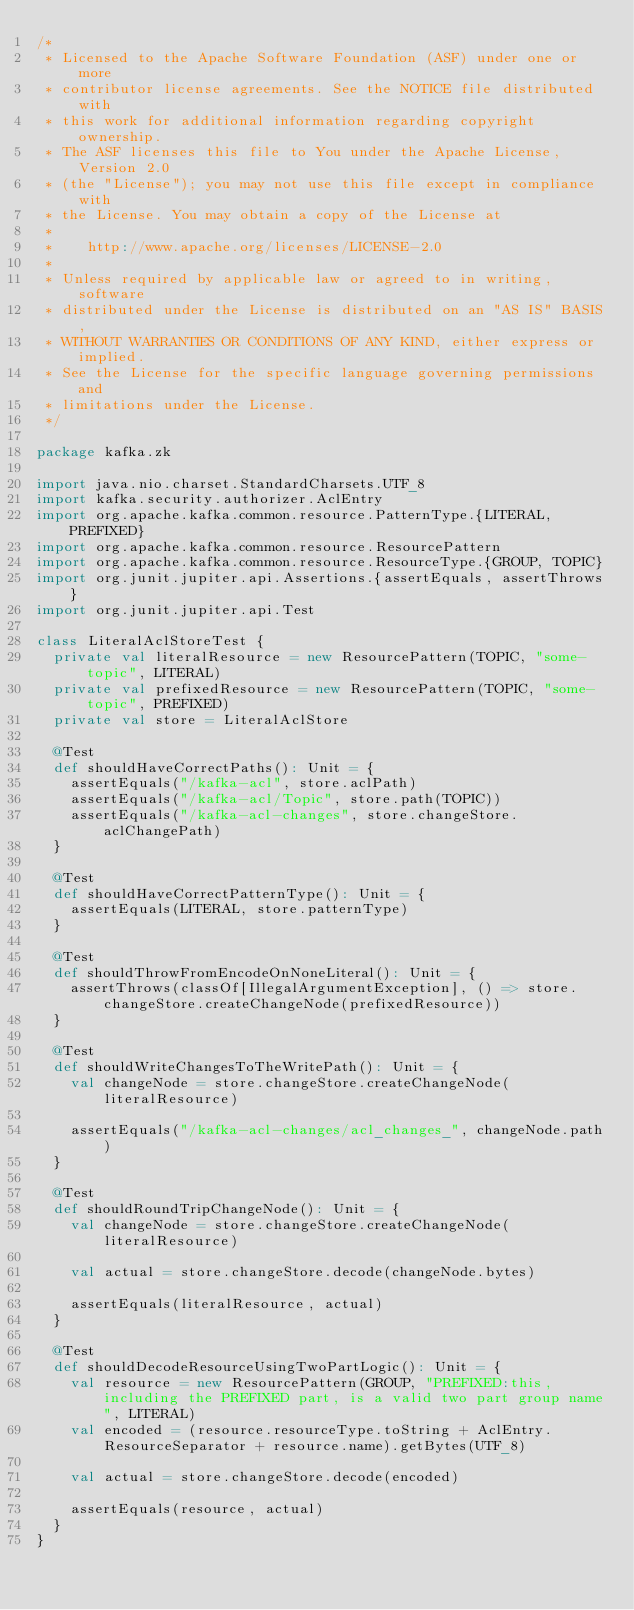Convert code to text. <code><loc_0><loc_0><loc_500><loc_500><_Scala_>/*
 * Licensed to the Apache Software Foundation (ASF) under one or more
 * contributor license agreements. See the NOTICE file distributed with
 * this work for additional information regarding copyright ownership.
 * The ASF licenses this file to You under the Apache License, Version 2.0
 * (the "License"); you may not use this file except in compliance with
 * the License. You may obtain a copy of the License at
 *
 *    http://www.apache.org/licenses/LICENSE-2.0
 *
 * Unless required by applicable law or agreed to in writing, software
 * distributed under the License is distributed on an "AS IS" BASIS,
 * WITHOUT WARRANTIES OR CONDITIONS OF ANY KIND, either express or implied.
 * See the License for the specific language governing permissions and
 * limitations under the License.
 */

package kafka.zk

import java.nio.charset.StandardCharsets.UTF_8
import kafka.security.authorizer.AclEntry
import org.apache.kafka.common.resource.PatternType.{LITERAL, PREFIXED}
import org.apache.kafka.common.resource.ResourcePattern
import org.apache.kafka.common.resource.ResourceType.{GROUP, TOPIC}
import org.junit.jupiter.api.Assertions.{assertEquals, assertThrows}
import org.junit.jupiter.api.Test

class LiteralAclStoreTest {
  private val literalResource = new ResourcePattern(TOPIC, "some-topic", LITERAL)
  private val prefixedResource = new ResourcePattern(TOPIC, "some-topic", PREFIXED)
  private val store = LiteralAclStore

  @Test
  def shouldHaveCorrectPaths(): Unit = {
    assertEquals("/kafka-acl", store.aclPath)
    assertEquals("/kafka-acl/Topic", store.path(TOPIC))
    assertEquals("/kafka-acl-changes", store.changeStore.aclChangePath)
  }

  @Test
  def shouldHaveCorrectPatternType(): Unit = {
    assertEquals(LITERAL, store.patternType)
  }

  @Test
  def shouldThrowFromEncodeOnNoneLiteral(): Unit = {
    assertThrows(classOf[IllegalArgumentException], () => store.changeStore.createChangeNode(prefixedResource))
  }

  @Test
  def shouldWriteChangesToTheWritePath(): Unit = {
    val changeNode = store.changeStore.createChangeNode(literalResource)

    assertEquals("/kafka-acl-changes/acl_changes_", changeNode.path)
  }

  @Test
  def shouldRoundTripChangeNode(): Unit = {
    val changeNode = store.changeStore.createChangeNode(literalResource)

    val actual = store.changeStore.decode(changeNode.bytes)

    assertEquals(literalResource, actual)
  }

  @Test
  def shouldDecodeResourceUsingTwoPartLogic(): Unit = {
    val resource = new ResourcePattern(GROUP, "PREFIXED:this, including the PREFIXED part, is a valid two part group name", LITERAL)
    val encoded = (resource.resourceType.toString + AclEntry.ResourceSeparator + resource.name).getBytes(UTF_8)

    val actual = store.changeStore.decode(encoded)

    assertEquals(resource, actual)
  }
}
</code> 